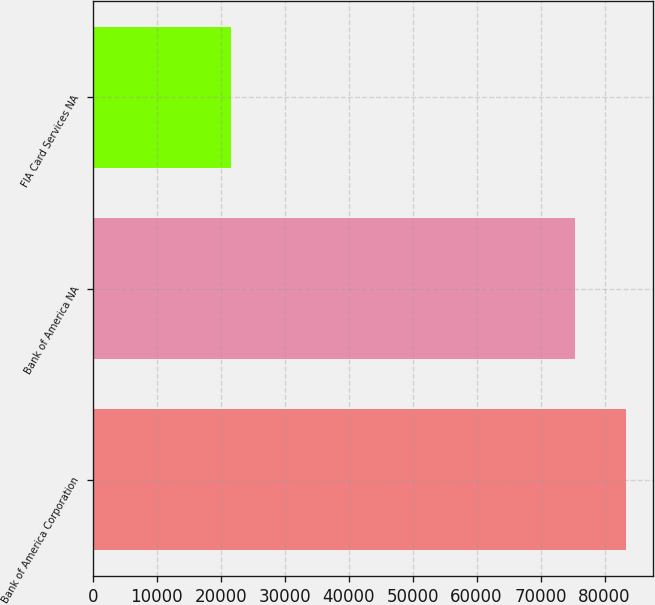Convert chart to OTSL. <chart><loc_0><loc_0><loc_500><loc_500><bar_chart><fcel>Bank of America Corporation<fcel>Bank of America NA<fcel>FIA Card Services NA<nl><fcel>83372<fcel>75395<fcel>21625<nl></chart> 